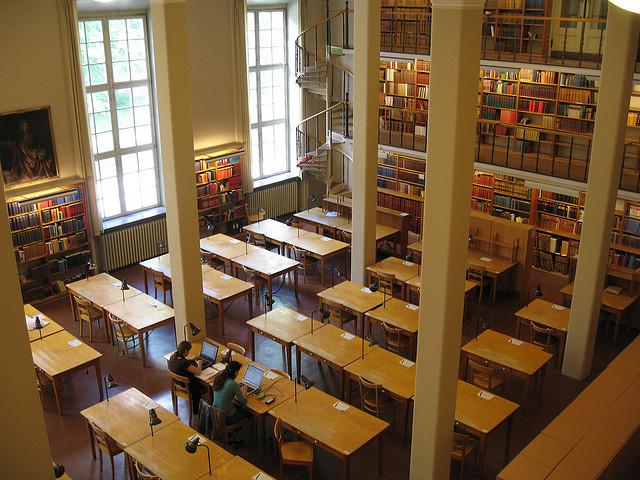Where was the photo taken of the man sitting behind a desk?
Give a very brief answer. Library. What are on the shelves?
Be succinct. Books. What color is the desk lamp?
Answer briefly. Black. Are there any open seats left?
Keep it brief. Yes. 